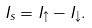<formula> <loc_0><loc_0><loc_500><loc_500>I _ { s } = I _ { \uparrow } - I _ { \downarrow } .</formula> 